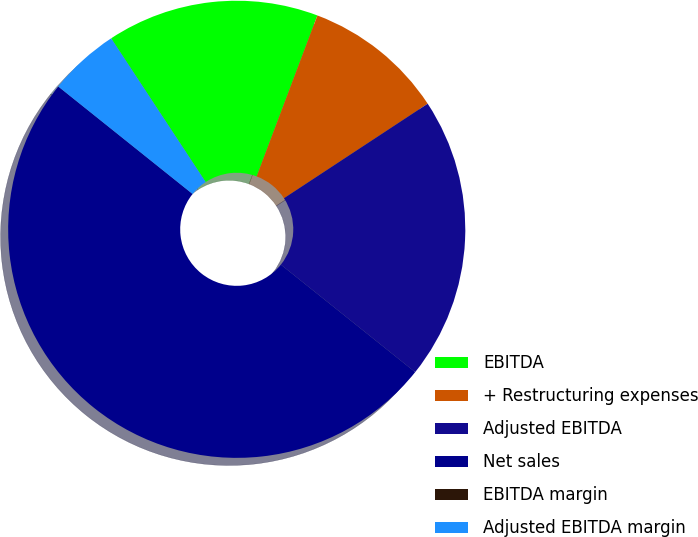<chart> <loc_0><loc_0><loc_500><loc_500><pie_chart><fcel>EBITDA<fcel>+ Restructuring expenses<fcel>Adjusted EBITDA<fcel>Net sales<fcel>EBITDA margin<fcel>Adjusted EBITDA margin<nl><fcel>15.0%<fcel>10.0%<fcel>20.0%<fcel>50.0%<fcel>0.0%<fcel>5.0%<nl></chart> 